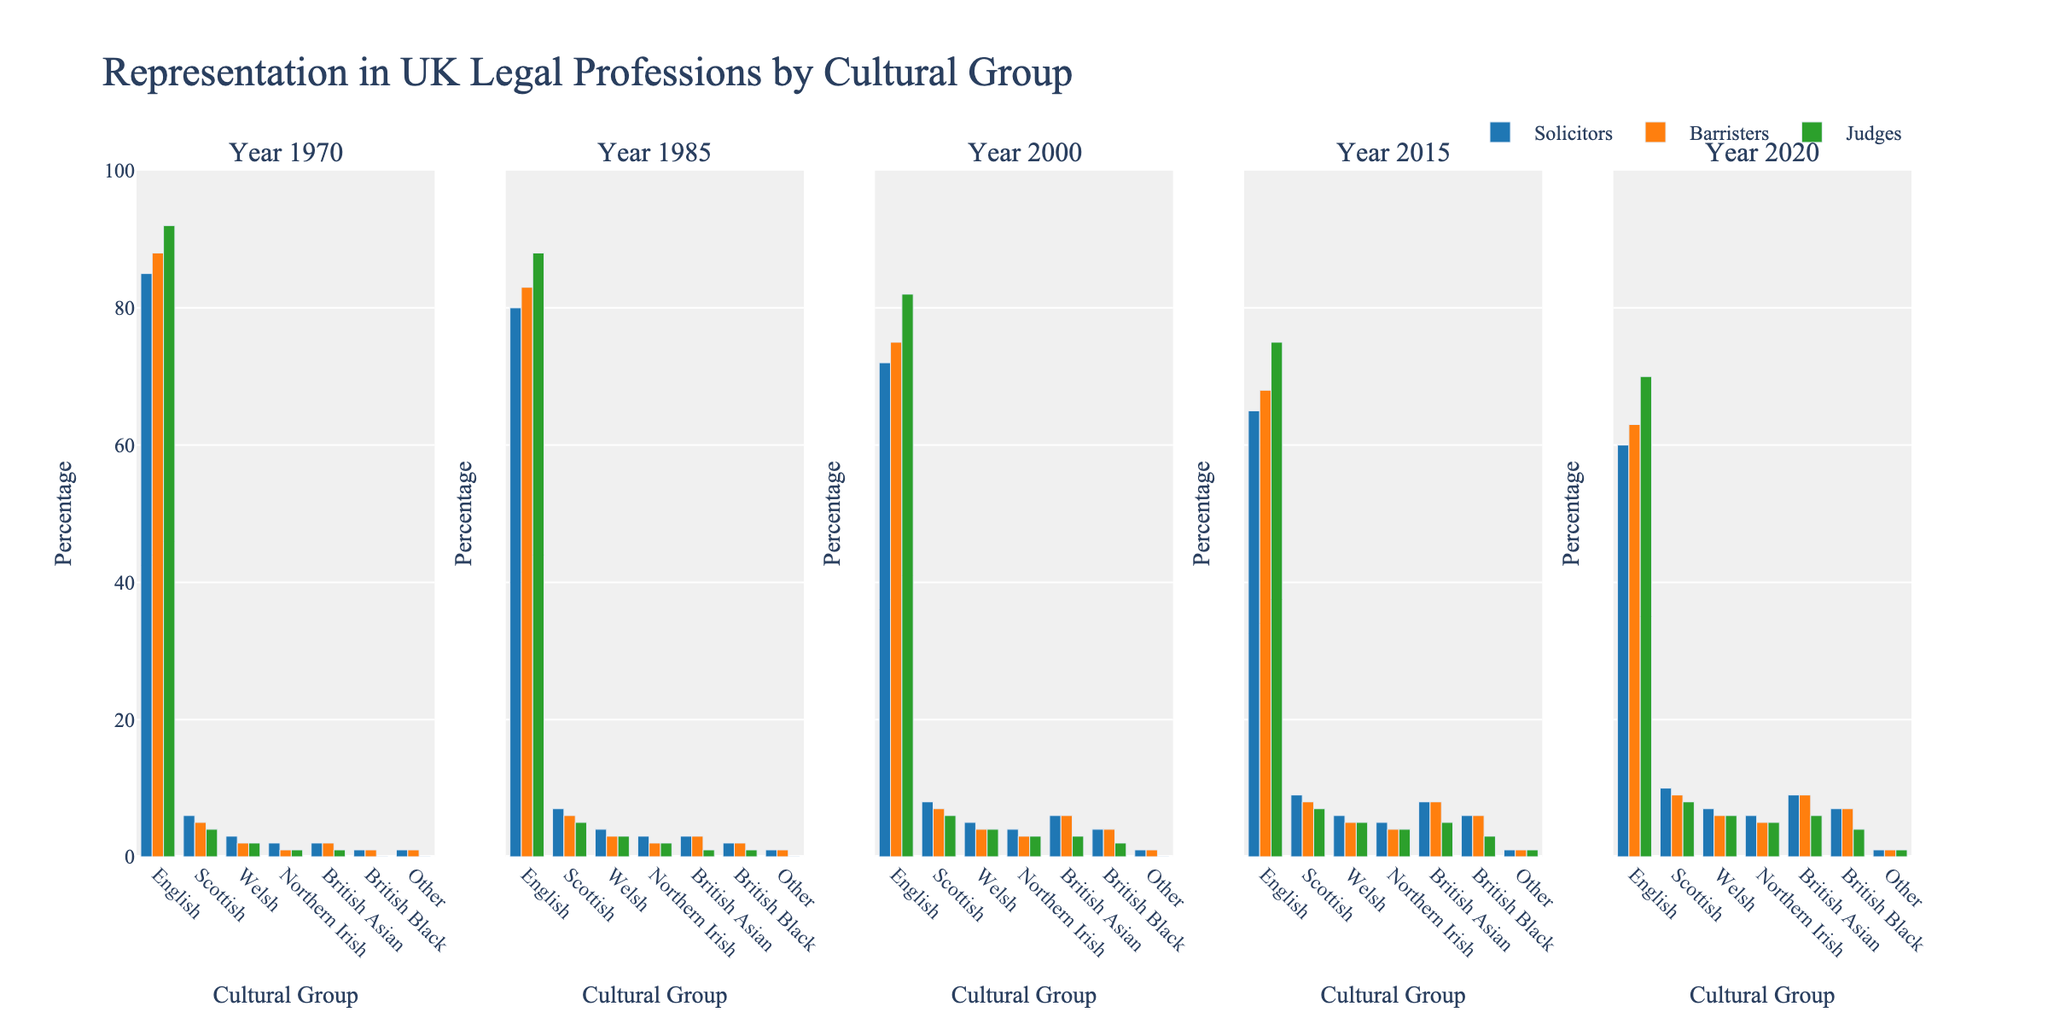Which cultural group had the smallest representation as solicitors in 2020? Looking at the subplot for the year 2020, under the Solicitors category, the bar for 'Other' is the shortest, indicating the smallest representation.
Answer: Other How did the representation of British Asian solicitors change from 1985 to 2020? Compare the height of the British Asian bar for Solicitors between the years 1985 and 2020. In 1985, the bar height was approximately 3, and in 2020, it was approximately 9.
Answer: Increased Which role had the highest percentage of English professionals in 1970? Looking at the subplot for 1970, the tallest bar in the English category corresponds to Judges, indicating they had the highest percentage.
Answer: Judges Between 2015 and 2020, which role saw a decrease in the percentage of English professionals? Comparing the heights of the English bars for each role between 2015 and 2020, the Judging role has the heights 75 and 70 respectively, indicating a decrease.
Answer: Judges Sum the percentage of Welsh professionals across all roles in the year 2000. Sum the heights of the Welsh bars for Solicitors, Barristers, and Judges in 2000 (5 + 4 + 4). Therefore, 5 + 4 + 4 = 13.
Answer: 13 Which cultural group saw the most significant increase in representation among solicitors from 1970 to 2000? Comparing the heights of the bars for each cultural group among Solicitors between 1970 and 2000, British Asian increased from 2 in 1970 to 6 in 2000. The increase is 6 - 2 = 4, which is the most significant change among all groups.
Answer: British Asian How does the representation of British Black barristers in 2015 compare to Judges in the same year? Compare the height of the British Black bars for Barristers and Judges in 2015. Both bars are approximately equal in height, around 6.
Answer: Equal What was the most prominent change for Scottish barristers from 1970 to 2020? According to the subplot, the bar for Scottish barristers in 1970 is around 5, and by 2020, it increases to around 9. Therefore, the most prominent change is an increase.
Answer: Increased 